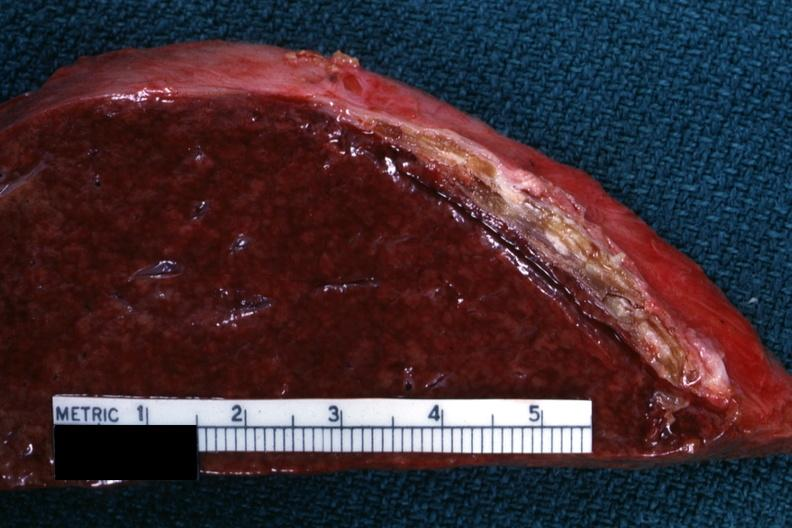what is present?
Answer the question using a single word or phrase. Hematologic 